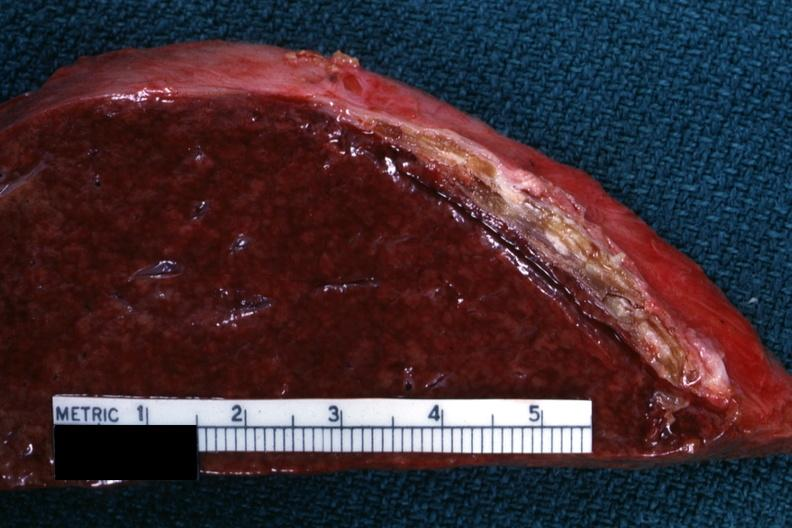what is present?
Answer the question using a single word or phrase. Hematologic 